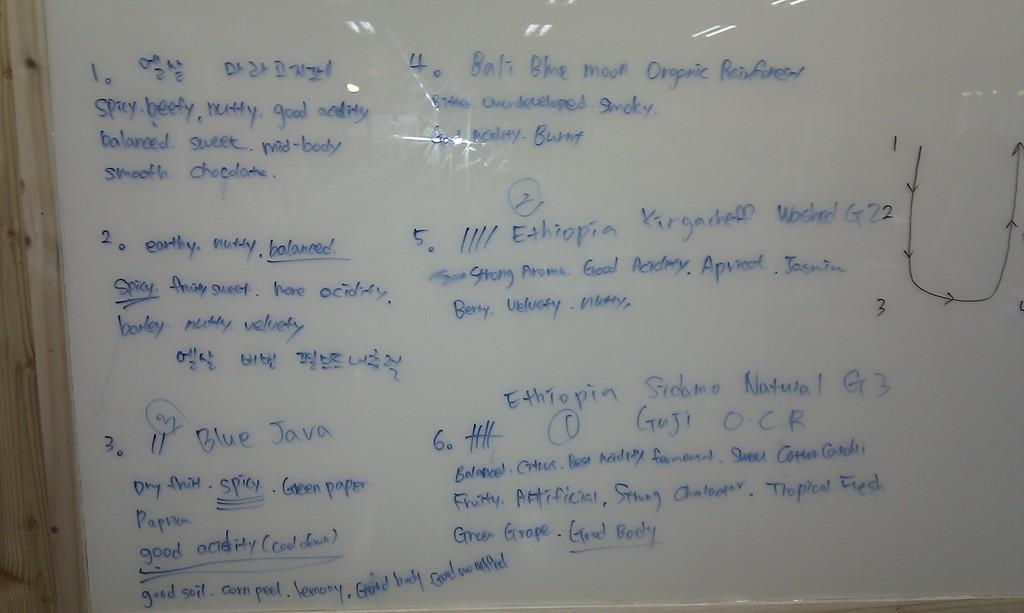<image>
Provide a brief description of the given image. the word earthy that is on a white board 